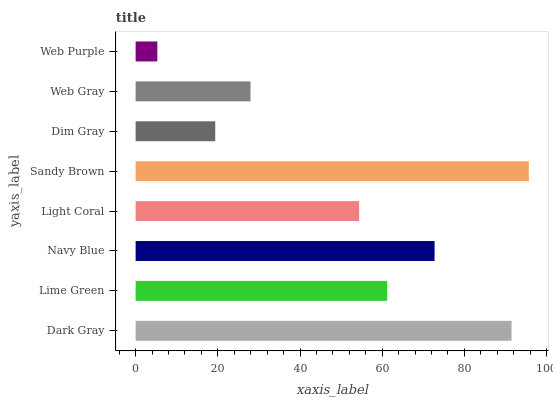Is Web Purple the minimum?
Answer yes or no. Yes. Is Sandy Brown the maximum?
Answer yes or no. Yes. Is Lime Green the minimum?
Answer yes or no. No. Is Lime Green the maximum?
Answer yes or no. No. Is Dark Gray greater than Lime Green?
Answer yes or no. Yes. Is Lime Green less than Dark Gray?
Answer yes or no. Yes. Is Lime Green greater than Dark Gray?
Answer yes or no. No. Is Dark Gray less than Lime Green?
Answer yes or no. No. Is Lime Green the high median?
Answer yes or no. Yes. Is Light Coral the low median?
Answer yes or no. Yes. Is Dim Gray the high median?
Answer yes or no. No. Is Lime Green the low median?
Answer yes or no. No. 